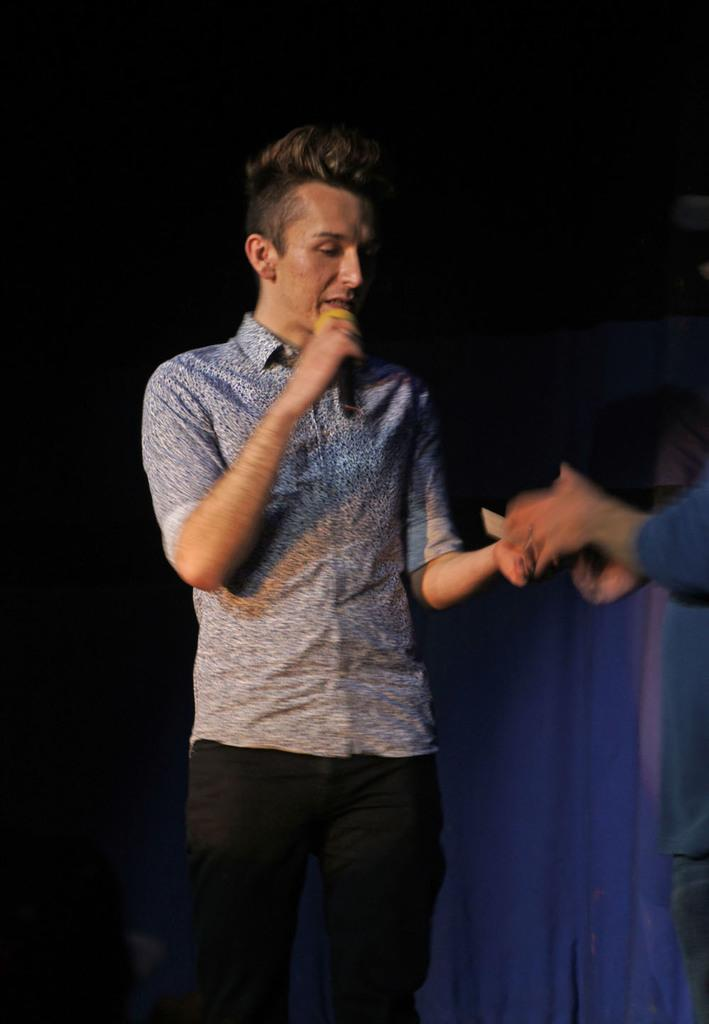Who or what is the main subject in the image? There is a person in the image. Can you describe the person's clothing? The person is wearing a blue color floral shirt. What is the person doing in the image? The person is standing and holding a microphone in his hand. What type of land can be seen in the background of the image? There is no land visible in the image; it only shows a person wearing a blue color floral shirt and holding a microphone. 